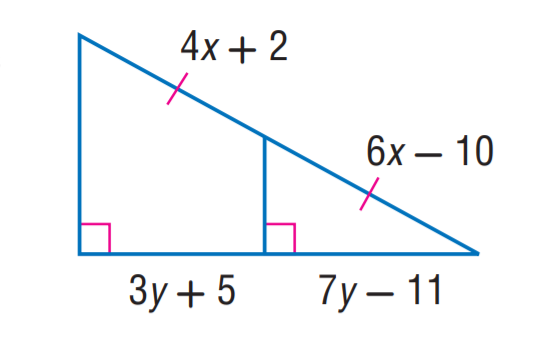Question: Find x.
Choices:
A. 3
B. 4
C. 5
D. 6
Answer with the letter. Answer: D 